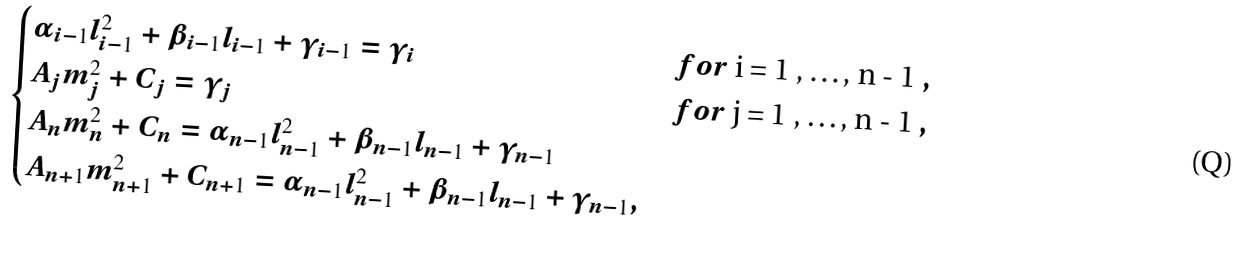Convert formula to latex. <formula><loc_0><loc_0><loc_500><loc_500>\begin{cases} \alpha _ { i - 1 } l _ { i - 1 } ^ { 2 } + \beta _ { i - 1 } l _ { i - 1 } + \gamma _ { i - 1 } = \gamma _ { i } & f o r $ i = 1 , \dots , n - 1 $ , \\ A _ { j } m _ { j } ^ { 2 } + C _ { j } = \gamma _ { j } & f o r $ j = 1 , \dots , n - 1 $ , \\ A _ { n } m _ { n } ^ { 2 } + C _ { n } = \alpha _ { n - 1 } l _ { n - 1 } ^ { 2 } + \beta _ { n - 1 } l _ { n - 1 } + \gamma _ { n - 1 } \\ A _ { n + 1 } m _ { n + 1 } ^ { 2 } + C _ { n + 1 } = \alpha _ { n - 1 } l _ { n - 1 } ^ { 2 } + \beta _ { n - 1 } l _ { n - 1 } + \gamma _ { n - 1 } , \end{cases}</formula> 